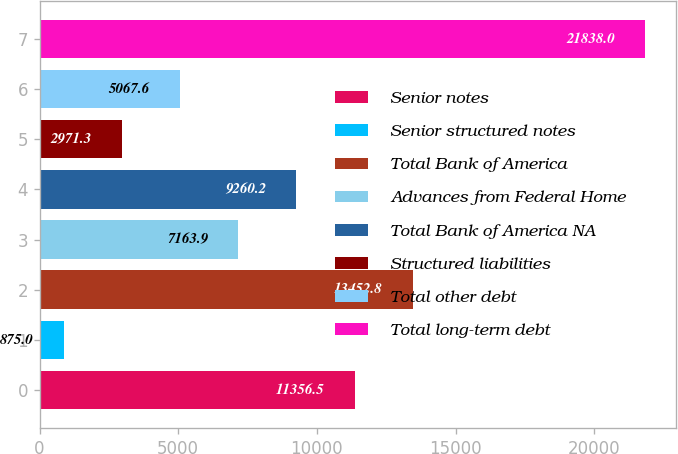Convert chart. <chart><loc_0><loc_0><loc_500><loc_500><bar_chart><fcel>Senior notes<fcel>Senior structured notes<fcel>Total Bank of America<fcel>Advances from Federal Home<fcel>Total Bank of America NA<fcel>Structured liabilities<fcel>Total other debt<fcel>Total long-term debt<nl><fcel>11356.5<fcel>875<fcel>13452.8<fcel>7163.9<fcel>9260.2<fcel>2971.3<fcel>5067.6<fcel>21838<nl></chart> 